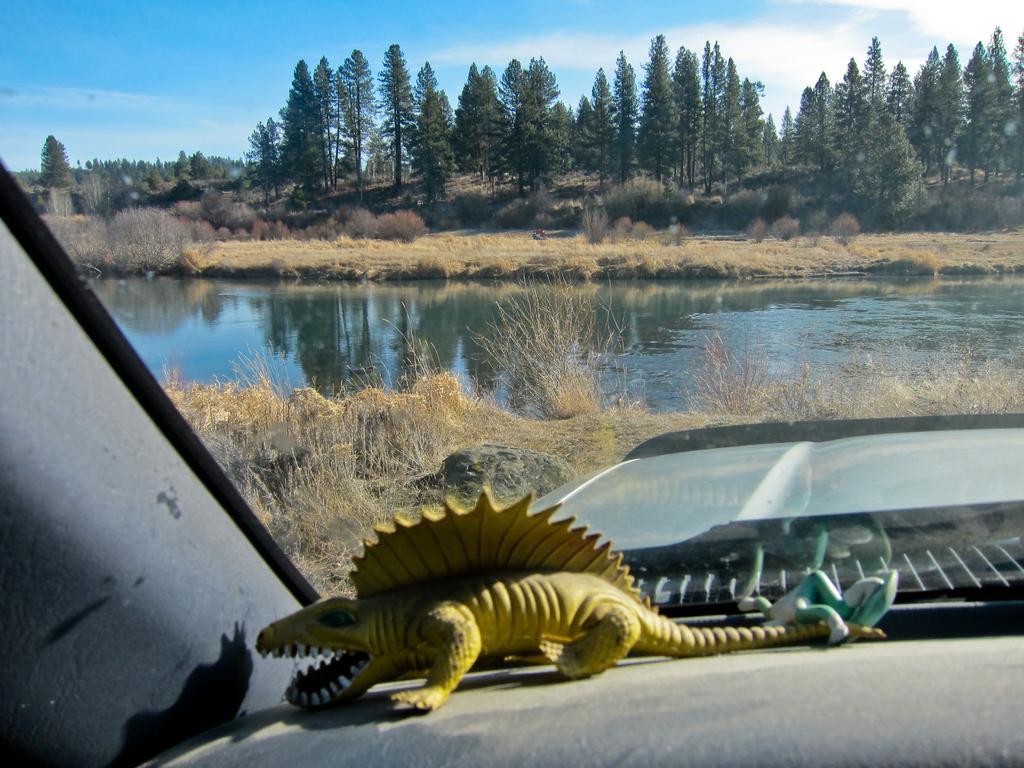How would you summarize this image in a sentence or two? In this picture we can see the inside view of a vehicle. In the vehicle, there are toys and a transparent glass. Behind the glass, there are plants, water, trees and the sky. 